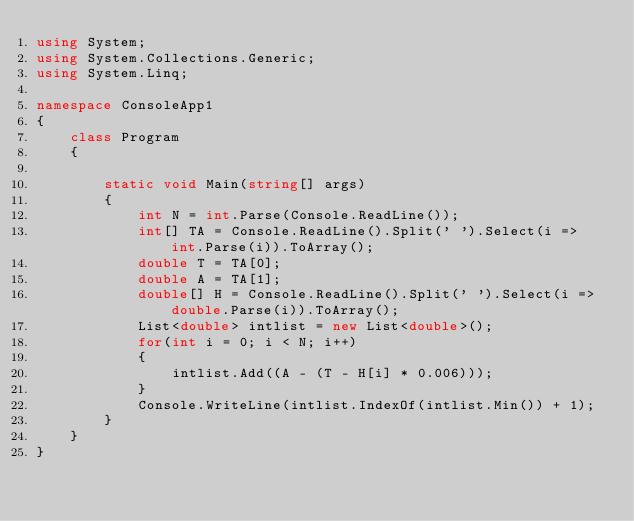Convert code to text. <code><loc_0><loc_0><loc_500><loc_500><_C#_>using System;
using System.Collections.Generic;
using System.Linq;

namespace ConsoleApp1
{
    class Program
    {
  
        static void Main(string[] args)
        {
            int N = int.Parse(Console.ReadLine());
            int[] TA = Console.ReadLine().Split(' ').Select(i => int.Parse(i)).ToArray();
            double T = TA[0];
            double A = TA[1];
            double[] H = Console.ReadLine().Split(' ').Select(i => double.Parse(i)).ToArray();
            List<double> intlist = new List<double>();
            for(int i = 0; i < N; i++)
            {
                intlist.Add((A - (T - H[i] * 0.006)));
            }
            Console.WriteLine(intlist.IndexOf(intlist.Min()) + 1);
        }
    }
}
</code> 